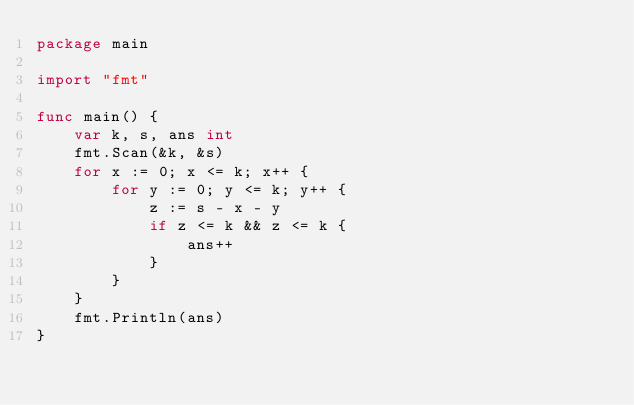<code> <loc_0><loc_0><loc_500><loc_500><_Go_>package main

import "fmt"

func main() {
	var k, s, ans int
	fmt.Scan(&k, &s)
	for x := 0; x <= k; x++ {
		for y := 0; y <= k; y++ {
			z := s - x - y
			if z <= k && z <= k {
				ans++
			}
		}
	}
	fmt.Println(ans)
}</code> 